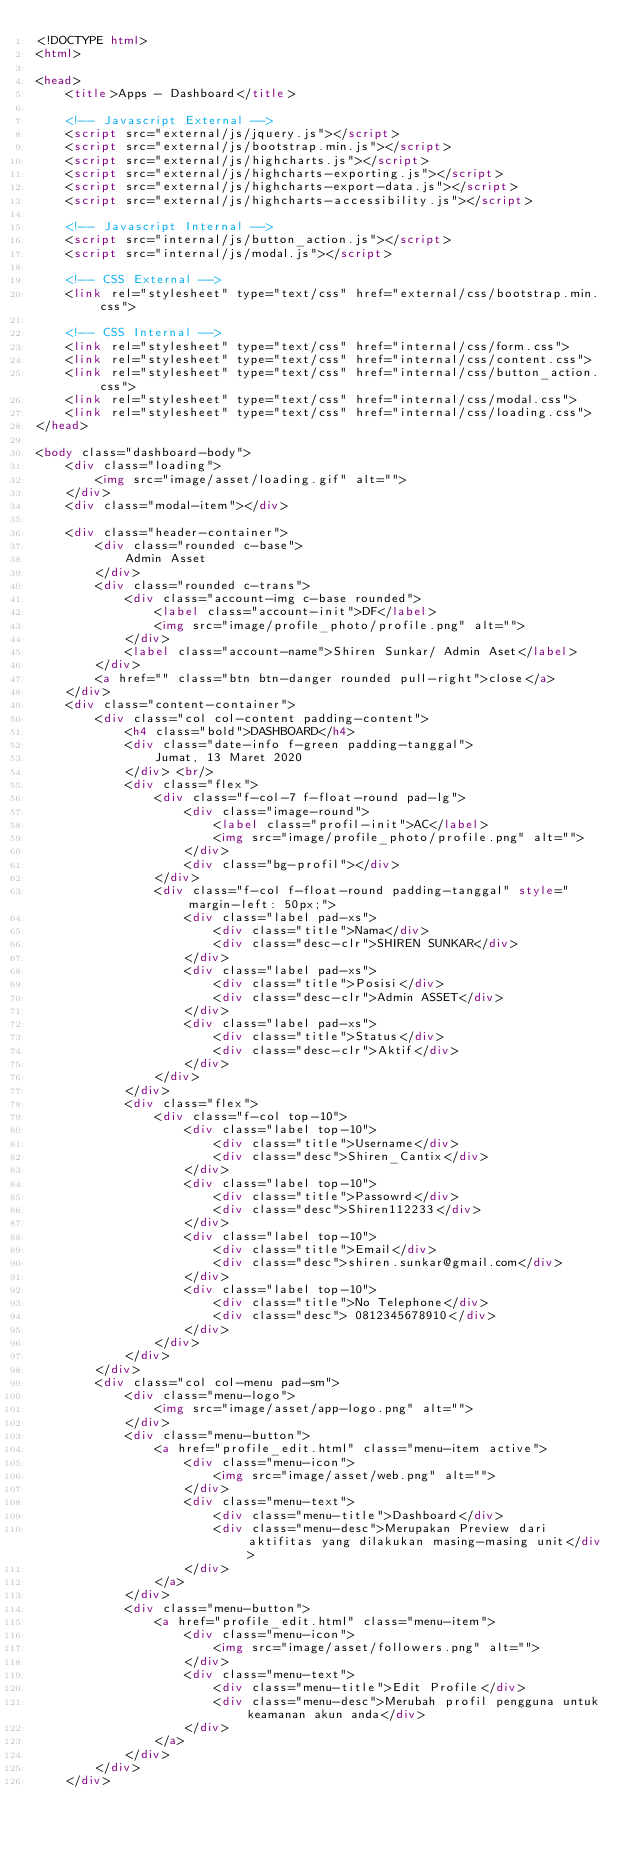<code> <loc_0><loc_0><loc_500><loc_500><_HTML_><!DOCTYPE html>
<html>

<head>
    <title>Apps - Dashboard</title>

    <!-- Javascript External -->
    <script src="external/js/jquery.js"></script>
    <script src="external/js/bootstrap.min.js"></script>
    <script src="external/js/highcharts.js"></script>
    <script src="external/js/highcharts-exporting.js"></script>
    <script src="external/js/highcharts-export-data.js"></script>
    <script src="external/js/highcharts-accessibility.js"></script>

    <!-- Javascript Internal -->
    <script src="internal/js/button_action.js"></script>
    <script src="internal/js/modal.js"></script>

    <!-- CSS External -->
    <link rel="stylesheet" type="text/css" href="external/css/bootstrap.min.css">

    <!-- CSS Internal -->
    <link rel="stylesheet" type="text/css" href="internal/css/form.css">
    <link rel="stylesheet" type="text/css" href="internal/css/content.css">
    <link rel="stylesheet" type="text/css" href="internal/css/button_action.css">
    <link rel="stylesheet" type="text/css" href="internal/css/modal.css">
    <link rel="stylesheet" type="text/css" href="internal/css/loading.css">
</head>

<body class="dashboard-body">
    <div class="loading">
        <img src="image/asset/loading.gif" alt="">
    </div>
    <div class="modal-item"></div>

    <div class="header-container">
        <div class="rounded c-base">
            Admin Asset
        </div>
        <div class="rounded c-trans">
            <div class="account-img c-base rounded">
                <label class="account-init">DF</label>
                <img src="image/profile_photo/profile.png" alt="">
            </div>
            <label class="account-name">Shiren Sunkar/ Admin Aset</label>
        </div>
        <a href="" class="btn btn-danger rounded pull-right">close</a>
    </div>
    <div class="content-container">
        <div class="col col-content padding-content">
			<h4 class="bold">DASHBOARD</h4>
			<div class="date-info f-green padding-tanggal">
				Jumat, 13 Maret 2020
            </div> <br/>
            <div class="flex">
                <div class="f-col-7 f-float-round pad-lg">
                    <div class="image-round">
                        <label class="profil-init">AC</label>
                        <img src="image/profile_photo/profile.png" alt="">
                    </div>
                    <div class="bg-profil"></div>
                </div>
                <div class="f-col f-float-round padding-tanggal" style="margin-left: 50px;">
                    <div class="label pad-xs">
                        <div class="title">Nama</div>
                        <div class="desc-clr">SHIREN SUNKAR</div>
                    </div>
                    <div class="label pad-xs">
                        <div class="title">Posisi</div>
                        <div class="desc-clr">Admin ASSET</div>
                    </div>
                    <div class="label pad-xs">
                        <div class="title">Status</div>
                        <div class="desc-clr">Aktif</div>
                    </div>
                </div>
            </div>
            <div class="flex">
                <div class="f-col top-10">
                    <div class="label top-10">
                        <div class="title">Username</div>
                        <div class="desc">Shiren_Cantix</div>
                    </div>
                    <div class="label top-10">
                        <div class="title">Passowrd</div>
                        <div class="desc">Shiren112233</div>
                    </div>
                    <div class="label top-10">
                        <div class="title">Email</div>
                        <div class="desc">shiren.sunkar@gmail.com</div>
                    </div>
                    <div class="label top-10">
                        <div class="title">No Telephone</div>
                        <div class="desc"> 0812345678910</div>
                    </div>
                </div>
            </div>       
        </div>
        <div class="col col-menu pad-sm">
            <div class="menu-logo">
                <img src="image/asset/app-logo.png" alt="">
            </div>
            <div class="menu-button">
                <a href="profile_edit.html" class="menu-item active">
                    <div class="menu-icon">
                        <img src="image/asset/web.png" alt="">
                    </div>
                    <div class="menu-text">
                        <div class="menu-title">Dashboard</div>
                        <div class="menu-desc">Merupakan Preview dari aktifitas yang dilakukan masing-masing unit</div>
                    </div>
                </a>
            </div>
            <div class="menu-button">
                <a href="profile_edit.html" class="menu-item">
                    <div class="menu-icon">
                        <img src="image/asset/followers.png" alt="">
                    </div>
                    <div class="menu-text">
                        <div class="menu-title">Edit Profile</div>
                        <div class="menu-desc">Merubah profil pengguna untuk keamanan akun anda</div>
                    </div>
                </a>
            </div>
        </div>
    </div></code> 